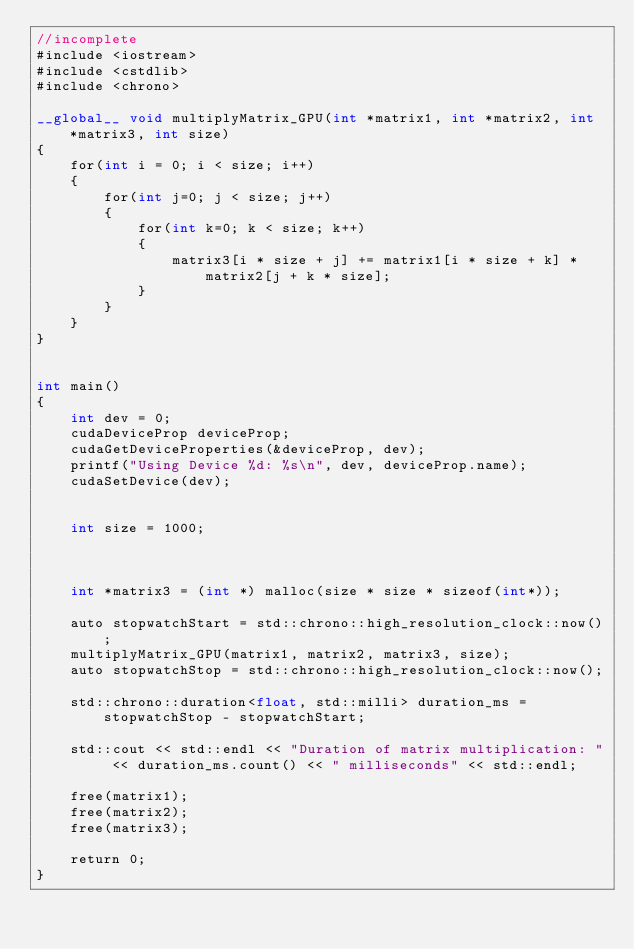Convert code to text. <code><loc_0><loc_0><loc_500><loc_500><_Cuda_>//incomplete
#include <iostream>
#include <cstdlib>
#include <chrono>

__global__ void multiplyMatrix_GPU(int *matrix1, int *matrix2, int *matrix3, int size) 
{
    for(int i = 0; i < size; i++) 
    {
        for(int j=0; j < size; j++) 
        {
            for(int k=0; k < size; k++) 
            {
                matrix3[i * size + j] += matrix1[i * size + k] * matrix2[j + k * size];
            }
        }
    }
}


int main()
{
    int dev = 0;
    cudaDeviceProp deviceProp;
    cudaGetDeviceProperties(&deviceProp, dev);
    printf("Using Device %d: %s\n", dev, deviceProp.name);
    cudaSetDevice(dev);


	int size = 1000;



	int *matrix3 = (int *) malloc(size * size * sizeof(int*));

	auto stopwatchStart = std::chrono::high_resolution_clock::now();
	multiplyMatrix_GPU(matrix1, matrix2, matrix3, size);
	auto stopwatchStop = std::chrono::high_resolution_clock::now();

	std::chrono::duration<float, std::milli> duration_ms = stopwatchStop - stopwatchStart;

	std::cout << std::endl << "Duration of matrix multiplication: " << duration_ms.count() << " milliseconds" << std::endl;

	free(matrix1);
	free(matrix2);
	free(matrix3);

	return 0;
}</code> 